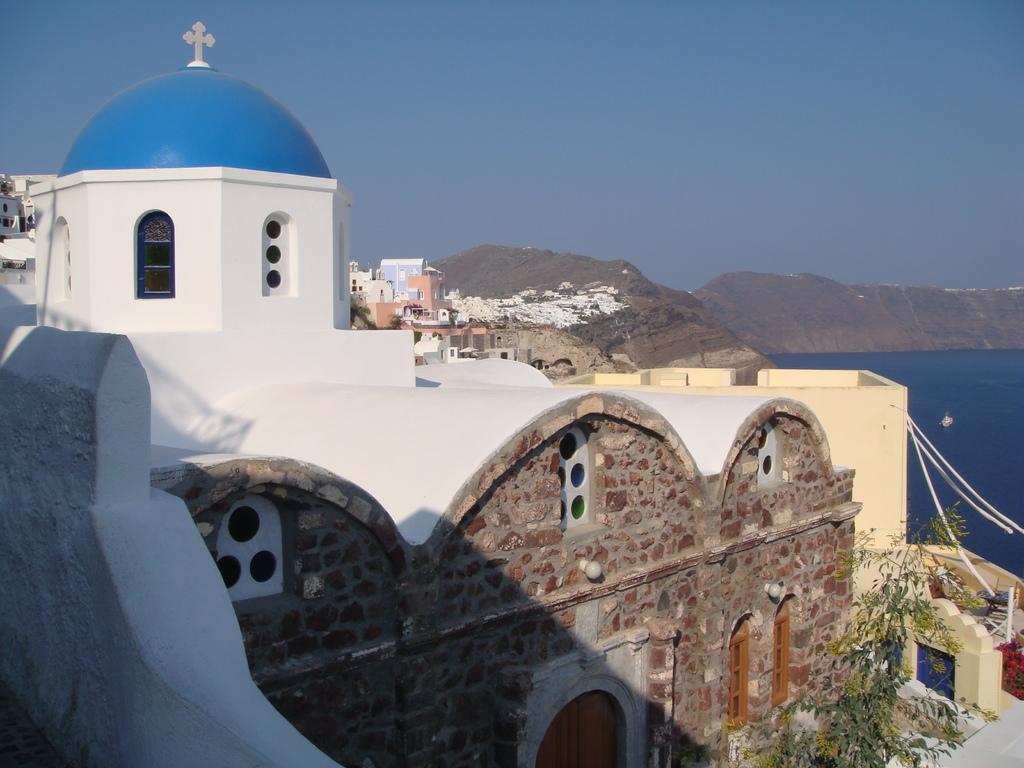Could you give a brief overview of what you see in this image? In this picture we can see buildings and some objects, here we can see plants and in the background we can see water, rocks, sky. 